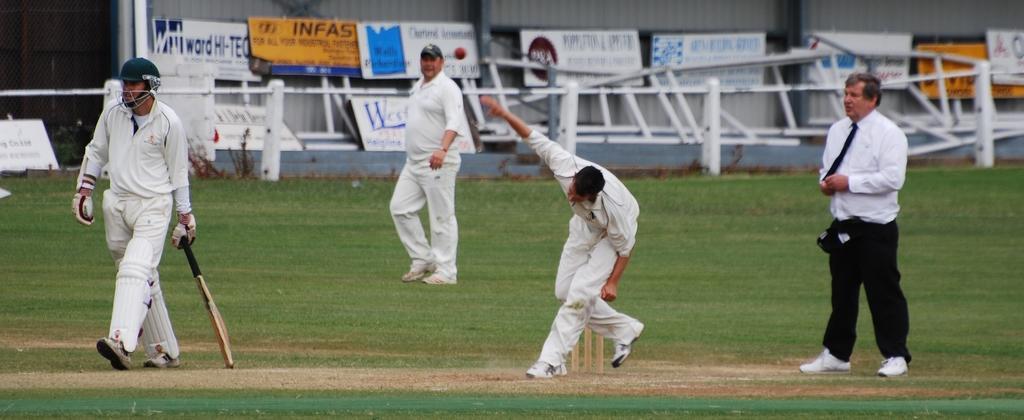Can you describe this image briefly? In the background we can see the walls, boards, railings, tiny plants. In this picture we can see the people playing the cricket game. We can see the red ball in the air. On the right side of the picture we can see an umpire. At the bottom portion of the picture we can see the green grass, green mat on the ground. 